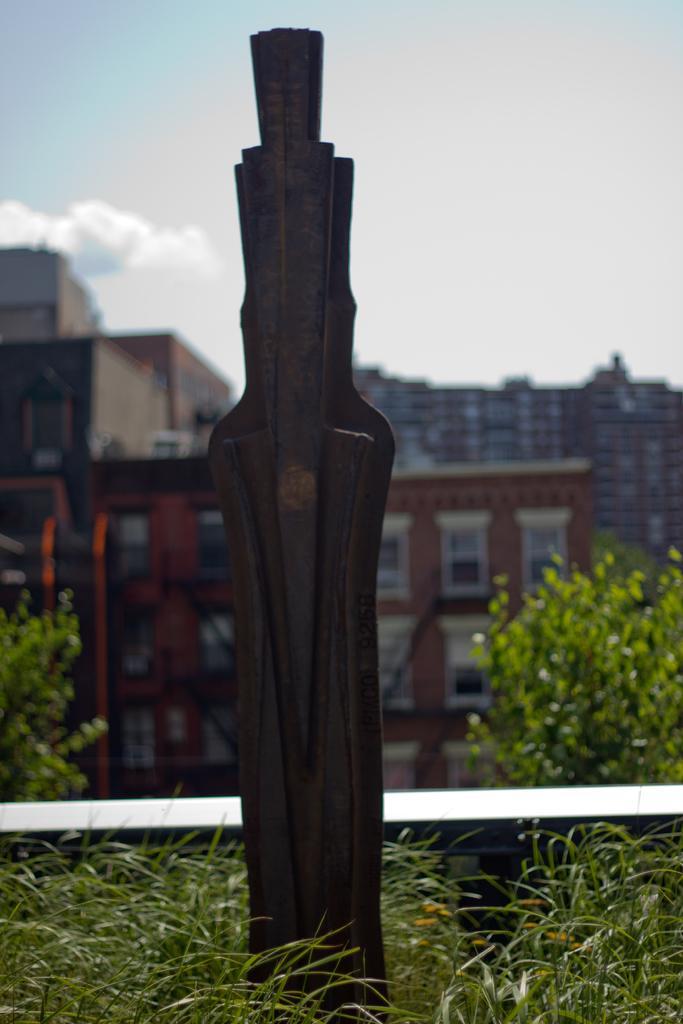Could you give a brief overview of what you see in this image? In this image in the front there's grass on the ground. In the background there are buildings, trees and the sky is cloudy and there is a wooden stick in the front. 